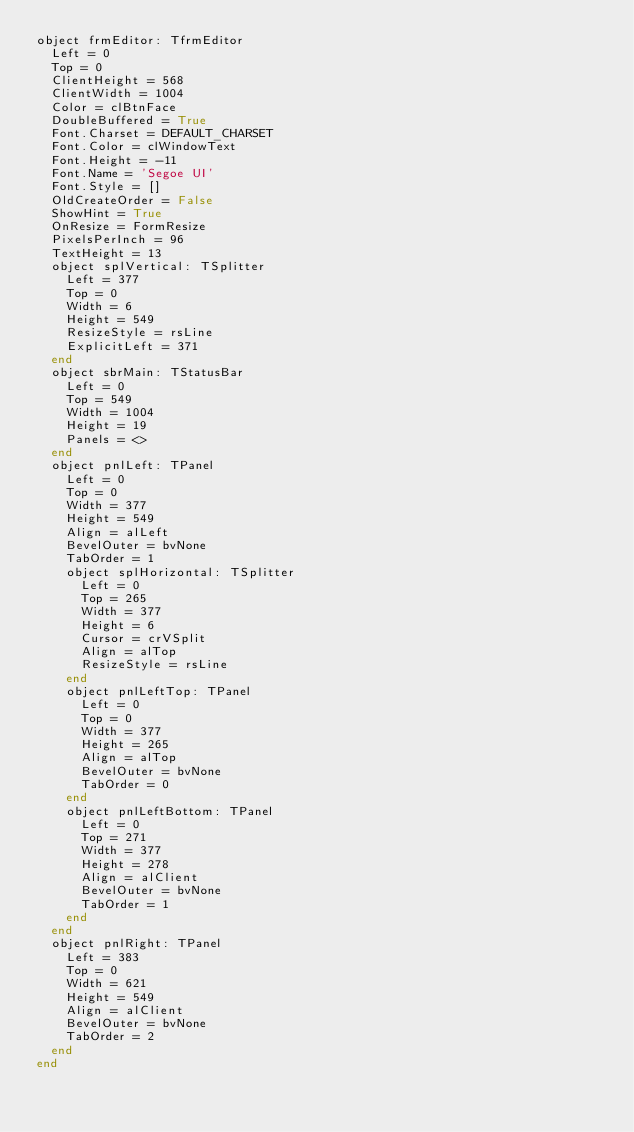<code> <loc_0><loc_0><loc_500><loc_500><_Pascal_>object frmEditor: TfrmEditor
  Left = 0
  Top = 0
  ClientHeight = 568
  ClientWidth = 1004
  Color = clBtnFace
  DoubleBuffered = True
  Font.Charset = DEFAULT_CHARSET
  Font.Color = clWindowText
  Font.Height = -11
  Font.Name = 'Segoe UI'
  Font.Style = []
  OldCreateOrder = False
  ShowHint = True
  OnResize = FormResize
  PixelsPerInch = 96
  TextHeight = 13
  object splVertical: TSplitter
    Left = 377
    Top = 0
    Width = 6
    Height = 549
    ResizeStyle = rsLine
    ExplicitLeft = 371
  end
  object sbrMain: TStatusBar
    Left = 0
    Top = 549
    Width = 1004
    Height = 19
    Panels = <>
  end
  object pnlLeft: TPanel
    Left = 0
    Top = 0
    Width = 377
    Height = 549
    Align = alLeft
    BevelOuter = bvNone
    TabOrder = 1
    object splHorizontal: TSplitter
      Left = 0
      Top = 265
      Width = 377
      Height = 6
      Cursor = crVSplit
      Align = alTop
      ResizeStyle = rsLine
    end
    object pnlLeftTop: TPanel
      Left = 0
      Top = 0
      Width = 377
      Height = 265
      Align = alTop
      BevelOuter = bvNone
      TabOrder = 0
    end
    object pnlLeftBottom: TPanel
      Left = 0
      Top = 271
      Width = 377
      Height = 278
      Align = alClient
      BevelOuter = bvNone
      TabOrder = 1
    end
  end
  object pnlRight: TPanel
    Left = 383
    Top = 0
    Width = 621
    Height = 549
    Align = alClient
    BevelOuter = bvNone
    TabOrder = 2
  end
end
</code> 